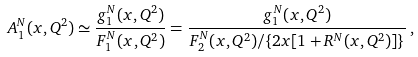Convert formula to latex. <formula><loc_0><loc_0><loc_500><loc_500>A _ { 1 } ^ { N } ( x , Q ^ { 2 } ) \simeq \frac { g _ { 1 } ^ { N } ( x , Q ^ { 2 } ) } { F _ { 1 } ^ { N } ( x , Q ^ { 2 } ) } = \frac { g _ { 1 } ^ { N } ( x , Q ^ { 2 } ) } { F _ { 2 } ^ { N } ( x , Q ^ { 2 } ) / \{ 2 x [ 1 + R ^ { N } ( x , Q ^ { 2 } ) ] \} } \, ,</formula> 